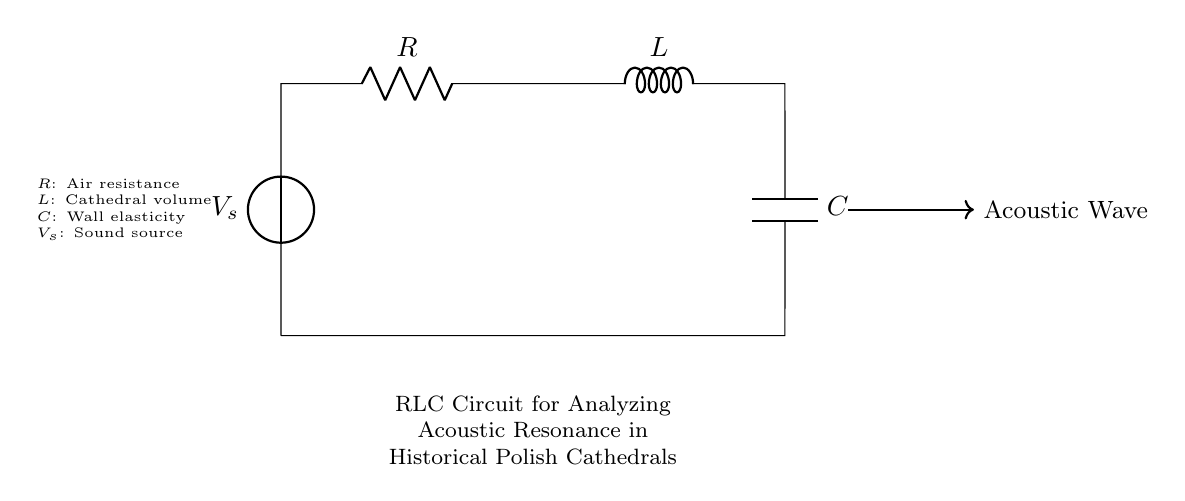What does the R in the circuit represent? The R in the circuit represents air resistance, which affects how sound travels through the cathedral space.
Answer: air resistance What is the role of the L component in this circuit? The L component, representing the cathedral volume, determines how much air can resonate within the space, influencing sound behavior.
Answer: cathedral volume How are the components connected in the circuit? The components are connected in series, as they are all connected one after another without any branching paths.
Answer: series What effect does increasing the C value have? Increasing the C value, which represents wall elasticity, enhances the capacity to store acoustic energy, leading to longer resonance times.
Answer: longer resonance What does the V_s symbol denote? The V_s symbol denotes the sound source that provides the input voltage or energy for the acoustic resonance in the circuit.
Answer: sound source What type of circuit is shown in the diagram? The circuit shown is a resonant RLC circuit, specifically designed to analyze acoustic resonance in spaces, such as cathedrals.
Answer: resonant RLC circuit How do you interpret the flow of an acoustic wave in this RLC circuit? The flow of the acoustic wave indicates how sound energy oscillates through the RLC components, which affects the resonance characteristics of the space.
Answer: oscillation 